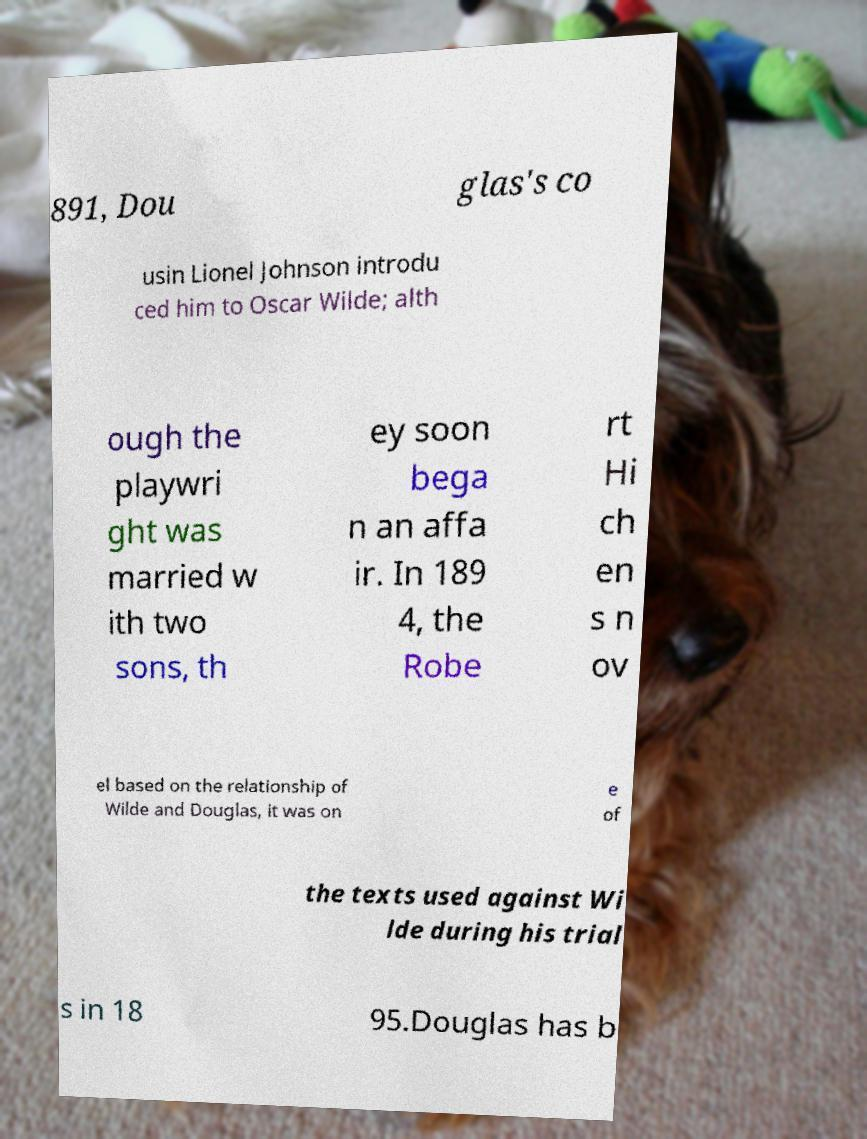Please read and relay the text visible in this image. What does it say? 891, Dou glas's co usin Lionel Johnson introdu ced him to Oscar Wilde; alth ough the playwri ght was married w ith two sons, th ey soon bega n an affa ir. In 189 4, the Robe rt Hi ch en s n ov el based on the relationship of Wilde and Douglas, it was on e of the texts used against Wi lde during his trial s in 18 95.Douglas has b 